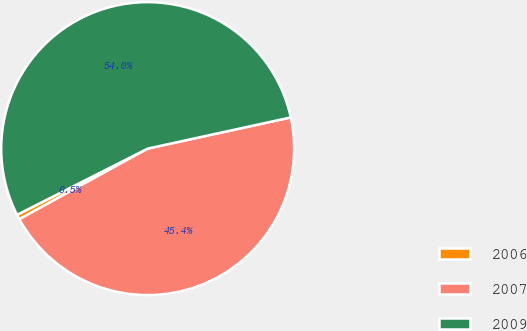Convert chart. <chart><loc_0><loc_0><loc_500><loc_500><pie_chart><fcel>2006<fcel>2007<fcel>2009<nl><fcel>0.54%<fcel>45.41%<fcel>54.05%<nl></chart> 